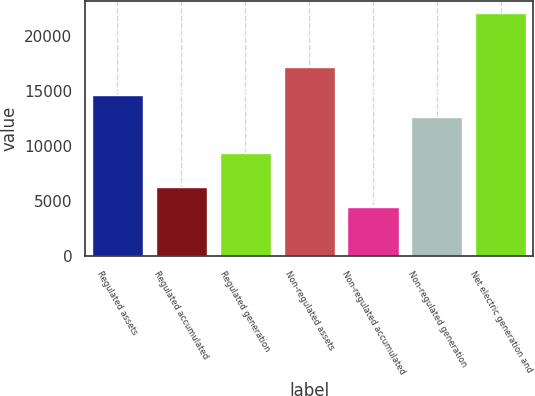Convert chart to OTSL. <chart><loc_0><loc_0><loc_500><loc_500><bar_chart><fcel>Regulated assets<fcel>Regulated accumulated<fcel>Regulated generation<fcel>Non-regulated assets<fcel>Non-regulated accumulated<fcel>Non-regulated generation<fcel>Net electric generation and<nl><fcel>14650<fcel>6263.2<fcel>9429<fcel>17187<fcel>4502<fcel>12685<fcel>22114<nl></chart> 